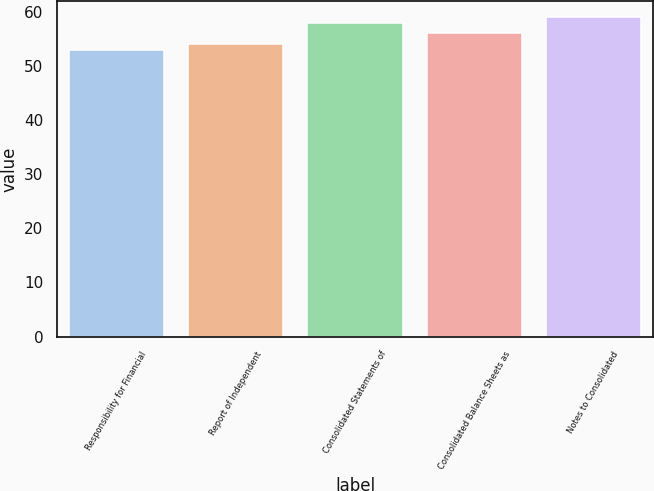Convert chart. <chart><loc_0><loc_0><loc_500><loc_500><bar_chart><fcel>Responsibility for Financial<fcel>Report of Independent<fcel>Consolidated Statements of<fcel>Consolidated Balance Sheets as<fcel>Notes to Consolidated<nl><fcel>53<fcel>54<fcel>58<fcel>56<fcel>59<nl></chart> 